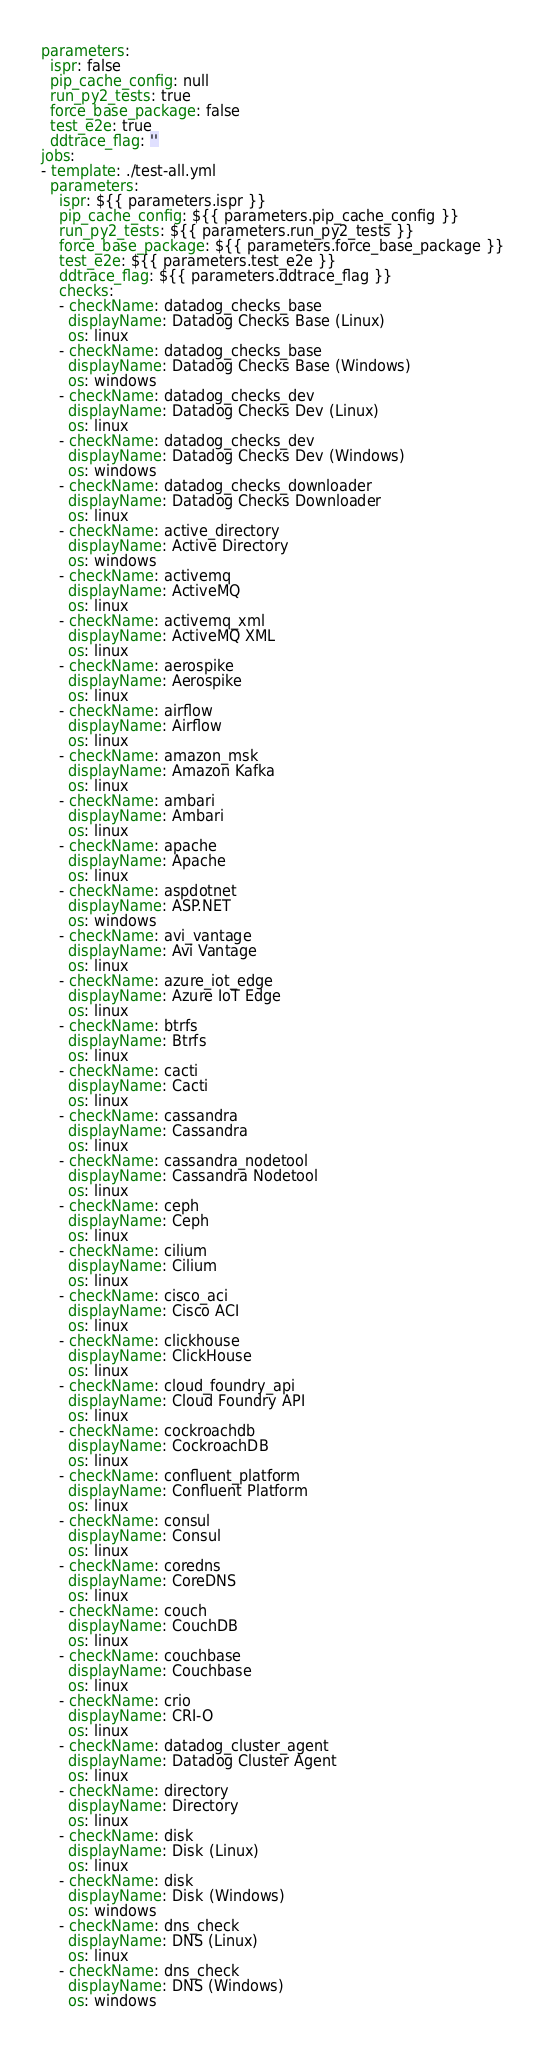Convert code to text. <code><loc_0><loc_0><loc_500><loc_500><_YAML_>parameters:
  ispr: false
  pip_cache_config: null
  run_py2_tests: true
  force_base_package: false
  test_e2e: true
  ddtrace_flag: ''
jobs:
- template: ./test-all.yml
  parameters:
    ispr: ${{ parameters.ispr }}
    pip_cache_config: ${{ parameters.pip_cache_config }}
    run_py2_tests: ${{ parameters.run_py2_tests }}
    force_base_package: ${{ parameters.force_base_package }}
    test_e2e: ${{ parameters.test_e2e }}
    ddtrace_flag: ${{ parameters.ddtrace_flag }}
    checks:
    - checkName: datadog_checks_base
      displayName: Datadog Checks Base (Linux)
      os: linux
    - checkName: datadog_checks_base
      displayName: Datadog Checks Base (Windows)
      os: windows
    - checkName: datadog_checks_dev
      displayName: Datadog Checks Dev (Linux)
      os: linux
    - checkName: datadog_checks_dev
      displayName: Datadog Checks Dev (Windows)
      os: windows
    - checkName: datadog_checks_downloader
      displayName: Datadog Checks Downloader
      os: linux
    - checkName: active_directory
      displayName: Active Directory
      os: windows
    - checkName: activemq
      displayName: ActiveMQ
      os: linux
    - checkName: activemq_xml
      displayName: ActiveMQ XML
      os: linux
    - checkName: aerospike
      displayName: Aerospike
      os: linux
    - checkName: airflow
      displayName: Airflow
      os: linux
    - checkName: amazon_msk
      displayName: Amazon Kafka
      os: linux
    - checkName: ambari
      displayName: Ambari
      os: linux
    - checkName: apache
      displayName: Apache
      os: linux
    - checkName: aspdotnet
      displayName: ASP.NET
      os: windows
    - checkName: avi_vantage
      displayName: Avi Vantage
      os: linux
    - checkName: azure_iot_edge
      displayName: Azure IoT Edge
      os: linux
    - checkName: btrfs
      displayName: Btrfs
      os: linux
    - checkName: cacti
      displayName: Cacti
      os: linux
    - checkName: cassandra
      displayName: Cassandra
      os: linux
    - checkName: cassandra_nodetool
      displayName: Cassandra Nodetool
      os: linux
    - checkName: ceph
      displayName: Ceph
      os: linux
    - checkName: cilium
      displayName: Cilium
      os: linux
    - checkName: cisco_aci
      displayName: Cisco ACI
      os: linux
    - checkName: clickhouse
      displayName: ClickHouse
      os: linux
    - checkName: cloud_foundry_api
      displayName: Cloud Foundry API
      os: linux
    - checkName: cockroachdb
      displayName: CockroachDB
      os: linux
    - checkName: confluent_platform
      displayName: Confluent Platform
      os: linux
    - checkName: consul
      displayName: Consul
      os: linux
    - checkName: coredns
      displayName: CoreDNS
      os: linux
    - checkName: couch
      displayName: CouchDB
      os: linux
    - checkName: couchbase
      displayName: Couchbase
      os: linux
    - checkName: crio
      displayName: CRI-O
      os: linux
    - checkName: datadog_cluster_agent
      displayName: Datadog Cluster Agent
      os: linux
    - checkName: directory
      displayName: Directory
      os: linux
    - checkName: disk
      displayName: Disk (Linux)
      os: linux
    - checkName: disk
      displayName: Disk (Windows)
      os: windows
    - checkName: dns_check
      displayName: DNS (Linux)
      os: linux
    - checkName: dns_check
      displayName: DNS (Windows)
      os: windows</code> 